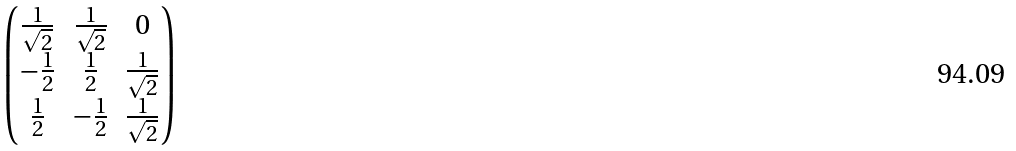<formula> <loc_0><loc_0><loc_500><loc_500>\begin{pmatrix} \frac { 1 } { \sqrt { 2 } } & \frac { 1 } { \sqrt { 2 } } & 0 \\ - \frac { 1 } { 2 } & \frac { 1 } { 2 } & \frac { 1 } { \sqrt { 2 } } \\ \frac { 1 } { 2 } & - \frac { 1 } { 2 } & \frac { 1 } { \sqrt { 2 } } \end{pmatrix}</formula> 